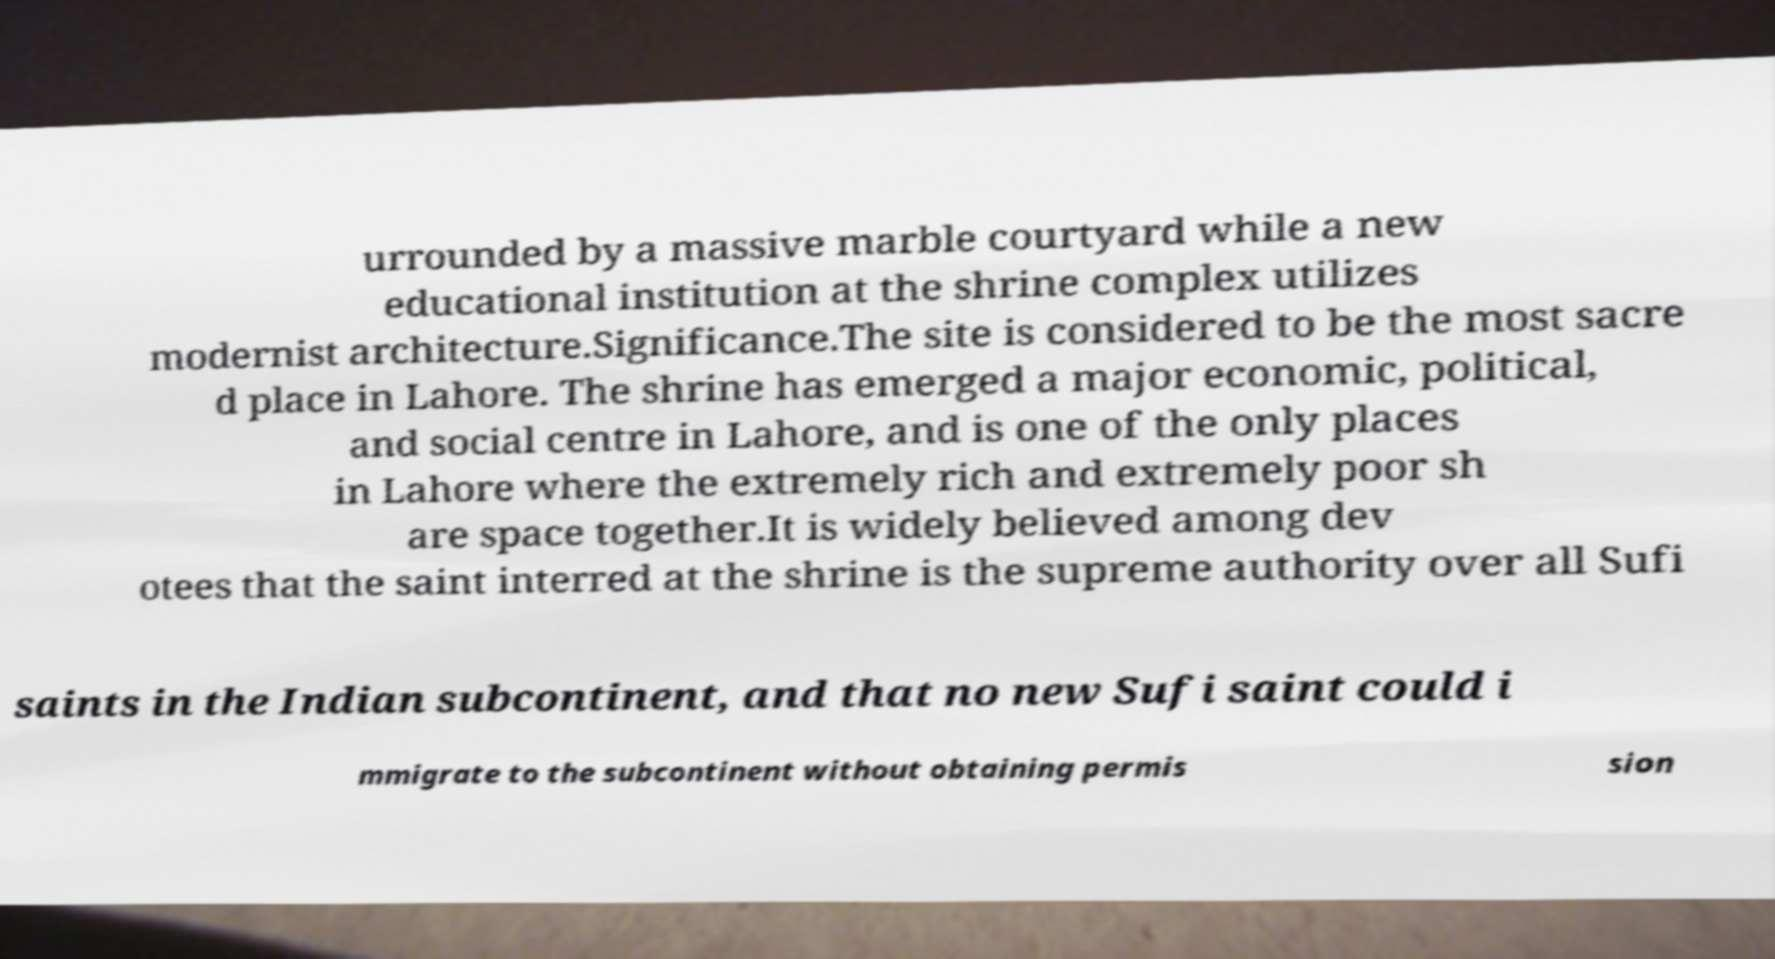Can you read and provide the text displayed in the image?This photo seems to have some interesting text. Can you extract and type it out for me? urrounded by a massive marble courtyard while a new educational institution at the shrine complex utilizes modernist architecture.Significance.The site is considered to be the most sacre d place in Lahore. The shrine has emerged a major economic, political, and social centre in Lahore, and is one of the only places in Lahore where the extremely rich and extremely poor sh are space together.It is widely believed among dev otees that the saint interred at the shrine is the supreme authority over all Sufi saints in the Indian subcontinent, and that no new Sufi saint could i mmigrate to the subcontinent without obtaining permis sion 